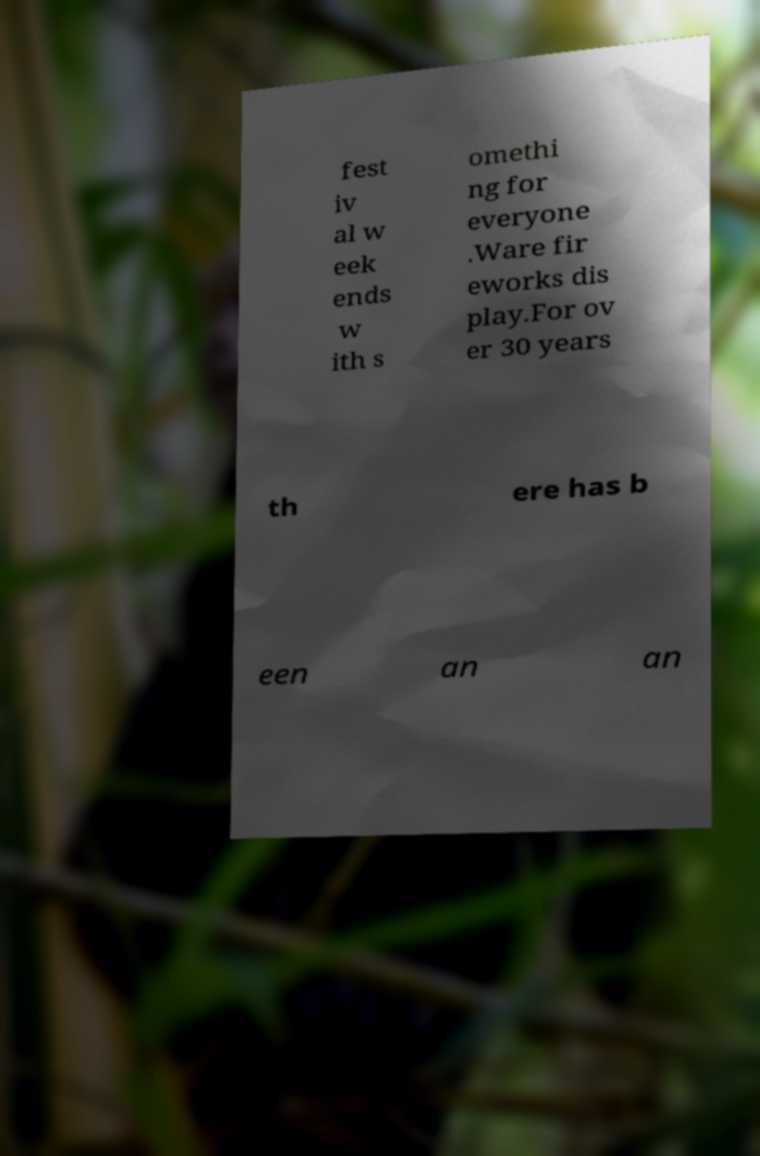Please read and relay the text visible in this image. What does it say? fest iv al w eek ends w ith s omethi ng for everyone .Ware fir eworks dis play.For ov er 30 years th ere has b een an an 